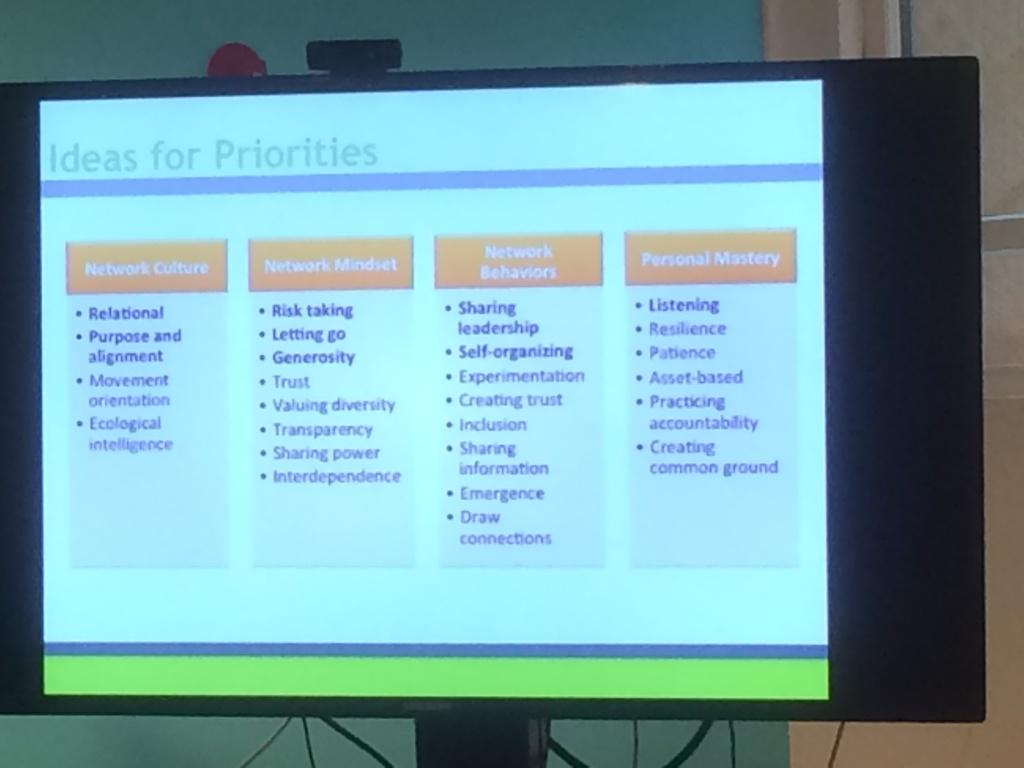<image>
Write a terse but informative summary of the picture. A computer screen with ideas for priorities open. 